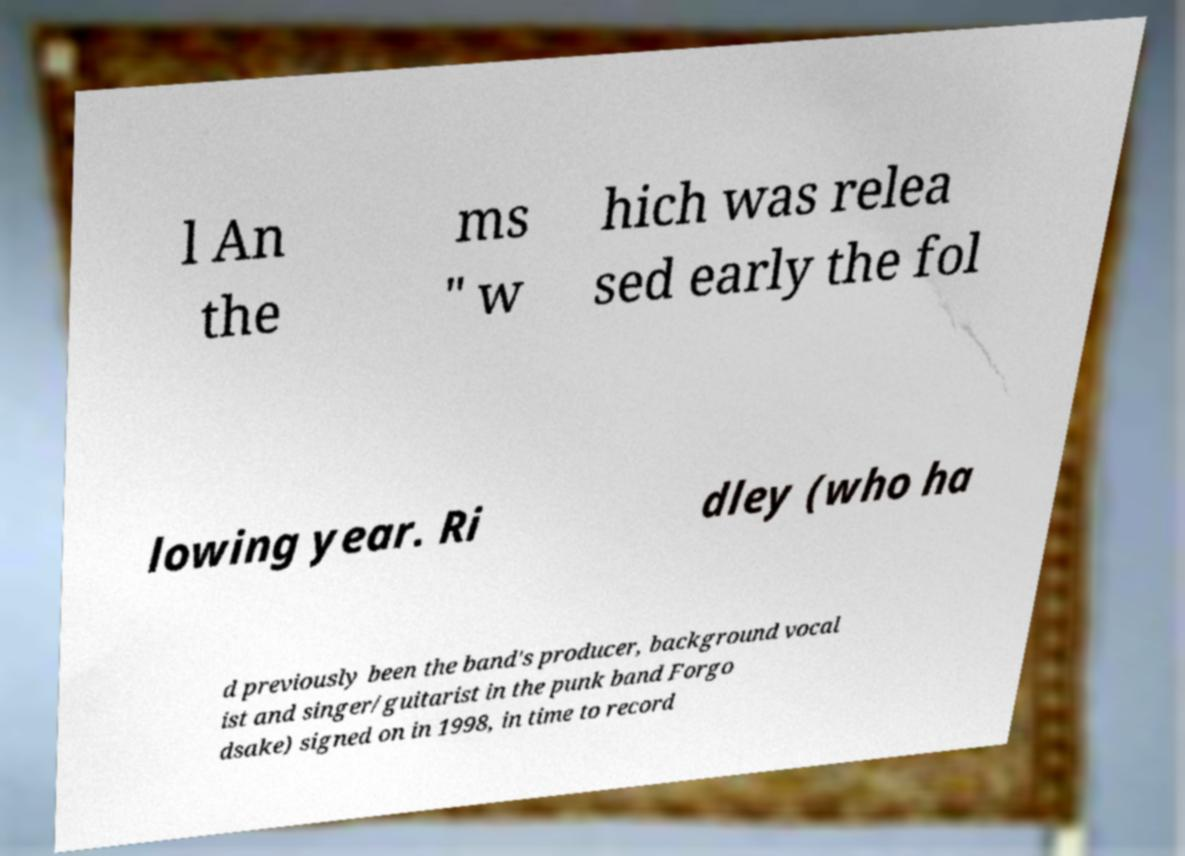Could you extract and type out the text from this image? l An the ms " w hich was relea sed early the fol lowing year. Ri dley (who ha d previously been the band's producer, background vocal ist and singer/guitarist in the punk band Forgo dsake) signed on in 1998, in time to record 